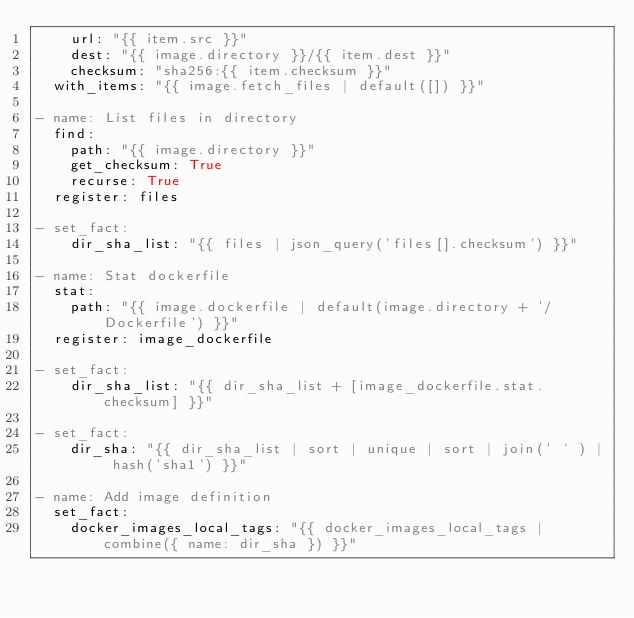<code> <loc_0><loc_0><loc_500><loc_500><_YAML_>    url: "{{ item.src }}"
    dest: "{{ image.directory }}/{{ item.dest }}"
    checksum: "sha256:{{ item.checksum }}"
  with_items: "{{ image.fetch_files | default([]) }}"

- name: List files in directory
  find:
    path: "{{ image.directory }}"
    get_checksum: True
    recurse: True
  register: files

- set_fact:
    dir_sha_list: "{{ files | json_query('files[].checksum') }}"

- name: Stat dockerfile
  stat:
    path: "{{ image.dockerfile | default(image.directory + '/Dockerfile') }}"
  register: image_dockerfile

- set_fact:
    dir_sha_list: "{{ dir_sha_list + [image_dockerfile.stat.checksum] }}"

- set_fact:
    dir_sha: "{{ dir_sha_list | sort | unique | sort | join(' ' ) | hash('sha1') }}"

- name: Add image definition
  set_fact:
    docker_images_local_tags: "{{ docker_images_local_tags | combine({ name: dir_sha }) }}"
</code> 